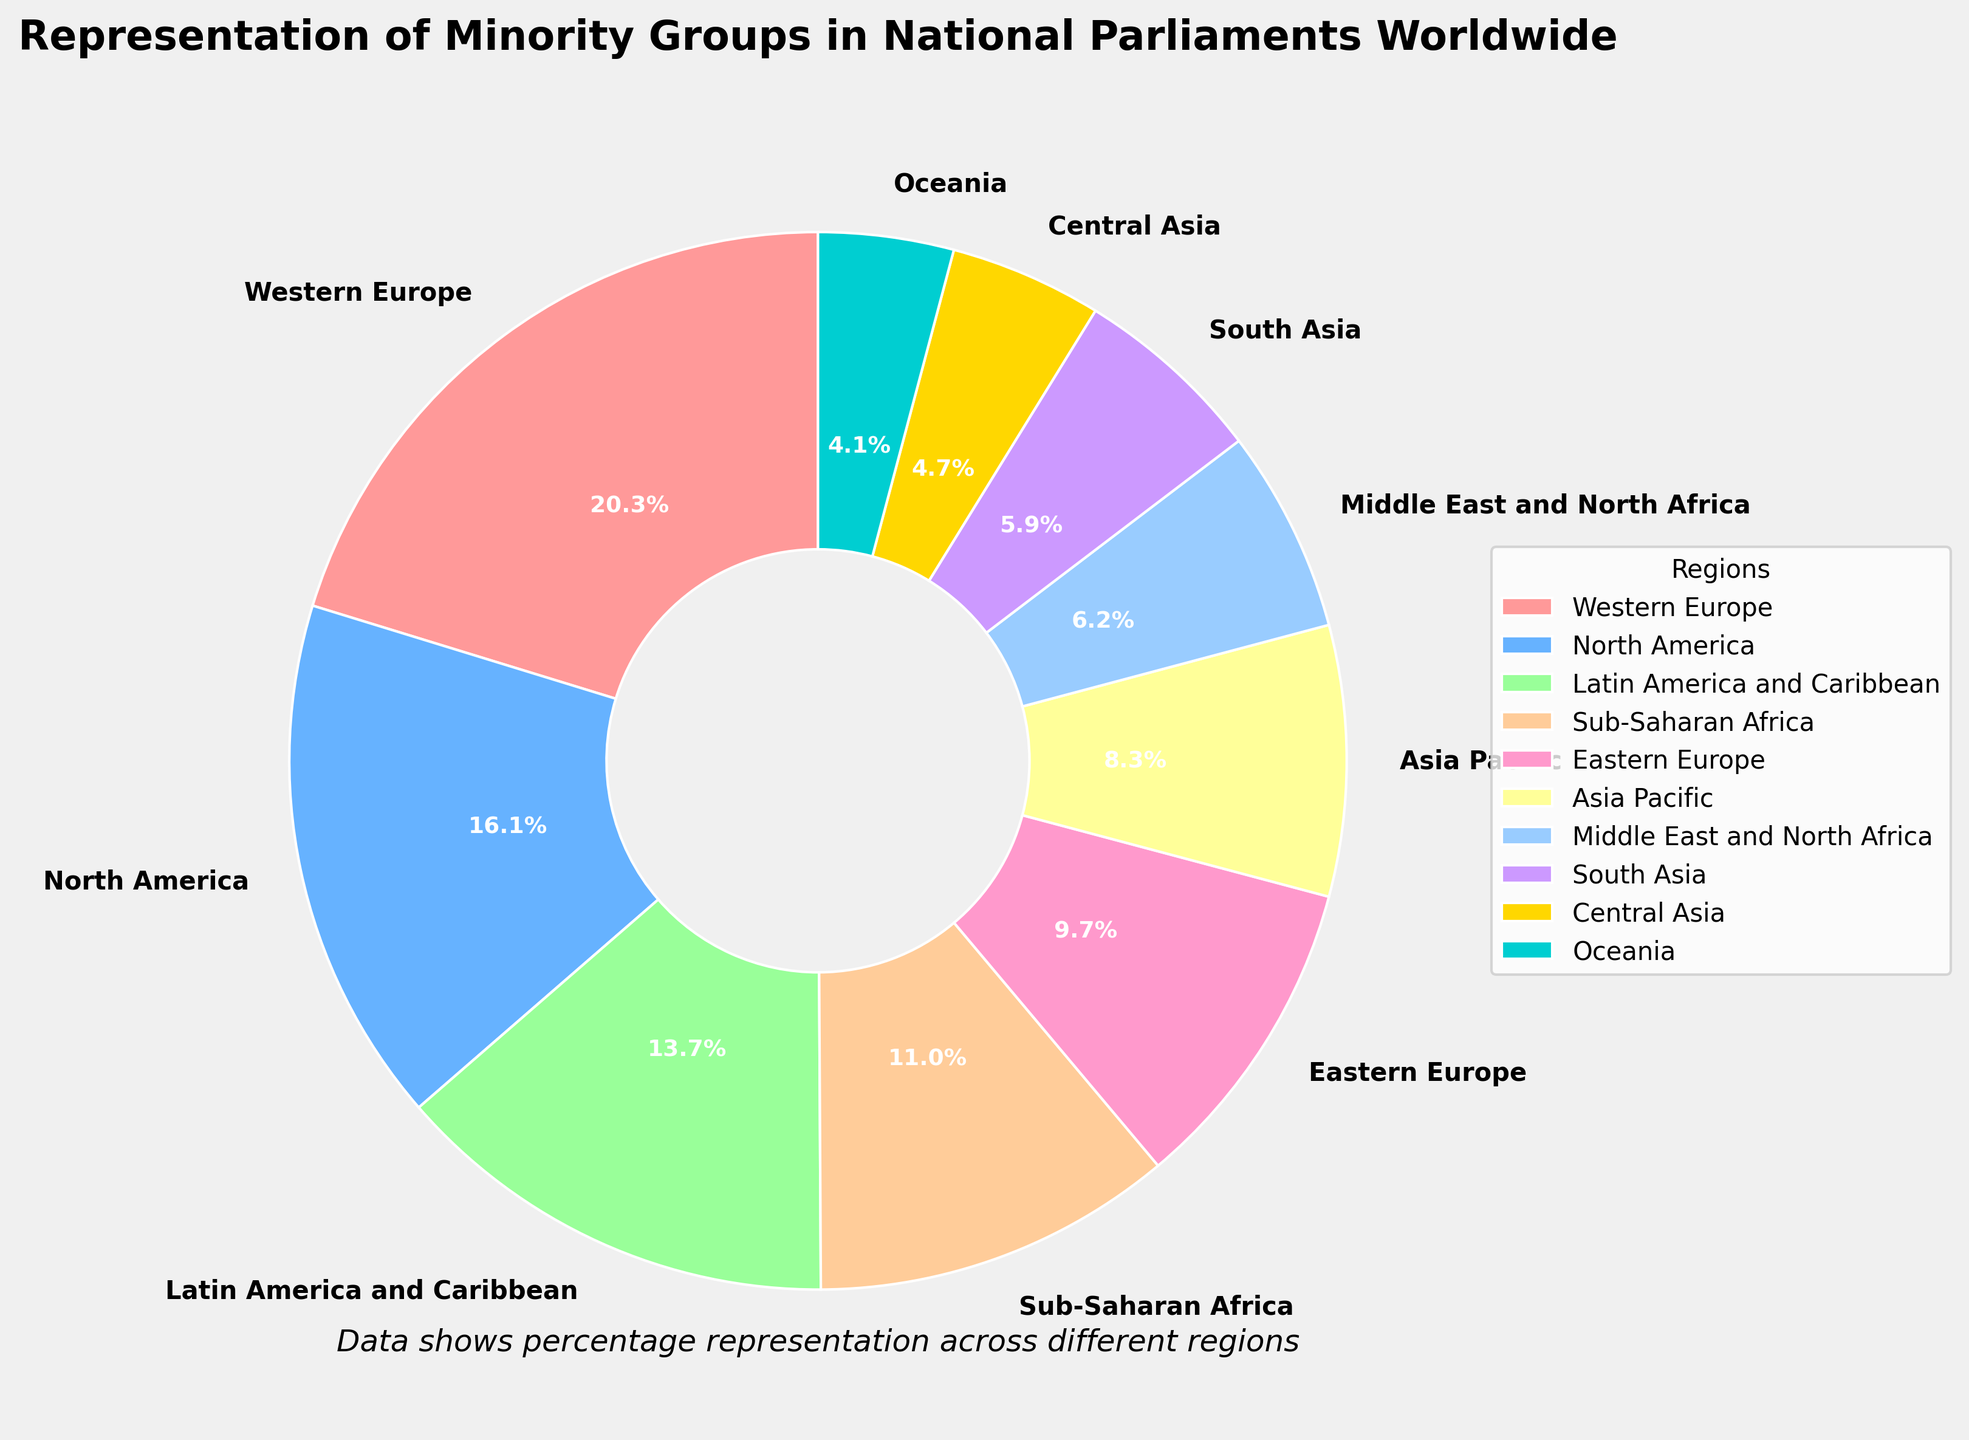Which region has the highest percentage of representation for minority groups in national parliaments? The figure shows the percentage representation of minority groups across different regions. Western Europe has the highest percentage at 23.5%, which can be identified as the largest segment in the pie chart.
Answer: Western Europe Which three regions have the lowest percentages of representation for minority groups? By looking at the pie chart, we can identify the smallest segments. The three regions with the lowest percentages are Oceania (4.8%), Central Asia (5.4%), and South Asia (6.8%).
Answer: Oceania, Central Asia, South Asia What is the total percentage of representation of minority groups for the regions Western Europe and North America combined? To find the combined percentage, add the percentages of Western Europe and North America. That is 23.5% + 18.7% = 42.2%.
Answer: 42.2% Which region has higher representation: Middle East and North Africa or Latin America and Caribbean? By comparing the segments representing Middle East and North Africa (7.2%) and Latin America and Caribbean (15.9%), we see that Latin America and Caribbean has a higher percentage.
Answer: Latin America and Caribbean What is the difference in percentage between the region with the highest and lowest representation? The difference is found by subtracting the smallest percentage from the largest. Western Europe has 23.5% and Oceania has 4.8%, so the difference is 23.5% - 4.8% = 18.7%.
Answer: 18.7% Which regions are represented by the color shades of green? The chart uses distinct colors for regions. By visually distinguishing the green shades, Sub-Saharan Africa (12.8%) and Latin America and Caribbean (15.9%) are represented by shades of green.
Answer: Sub-Saharan Africa, Latin America and Caribbean Is the representation of Asia Pacific higher or lower than Eastern Europe? Comparing their segments, Asia Pacific has 9.6% while Eastern Europe has 11.3%, so Asia Pacific has a lower representation.
Answer: Lower Which region contributes exactly 9.6% to the representation of minority groups in national parliaments? By checking the labels corresponding to the pie chart segments, Asia Pacific contributes exactly 9.6%.
Answer: Asia Pacific What is the average percentage of representation for the regions with more than 10% representation? Regions with more than 10% are Western Europe (23.5%), North America (18.7%), Latin America and Caribbean (15.9%), and Sub-Saharan Africa (12.8%). Their average is calculated as (23.5 + 18.7 + 15.9 + 12.8) / 4 = 70.9 / 4 = 17.725%.
Answer: 17.725% What is the combined representation percentage for the regions in the Middle East and North Africa and South Asia combined? Summing up their percentages: Middle East and North Africa (7.2%) + South Asia (6.8%) = 7.2% + 6.8% = 14.0%.
Answer: 14.0% 